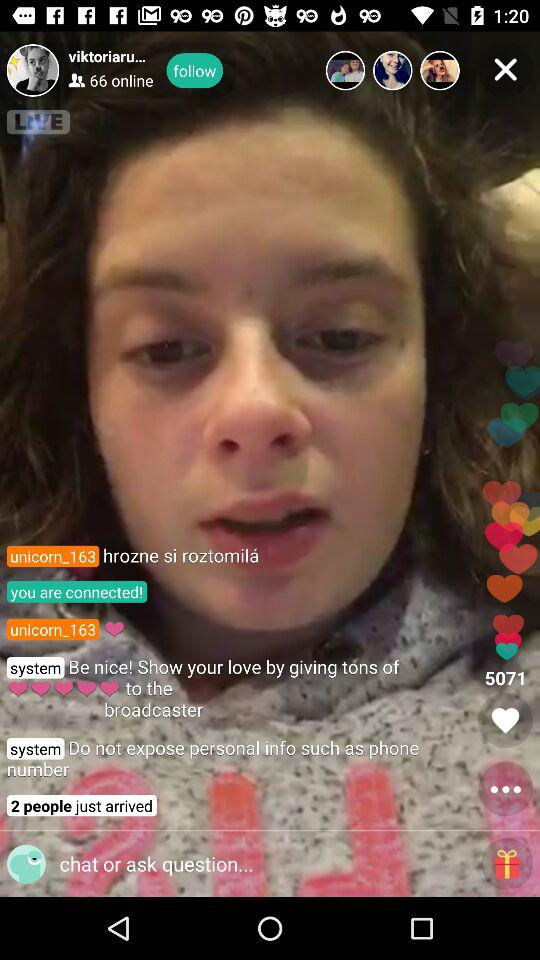How many users are online? There are 66 users online. 